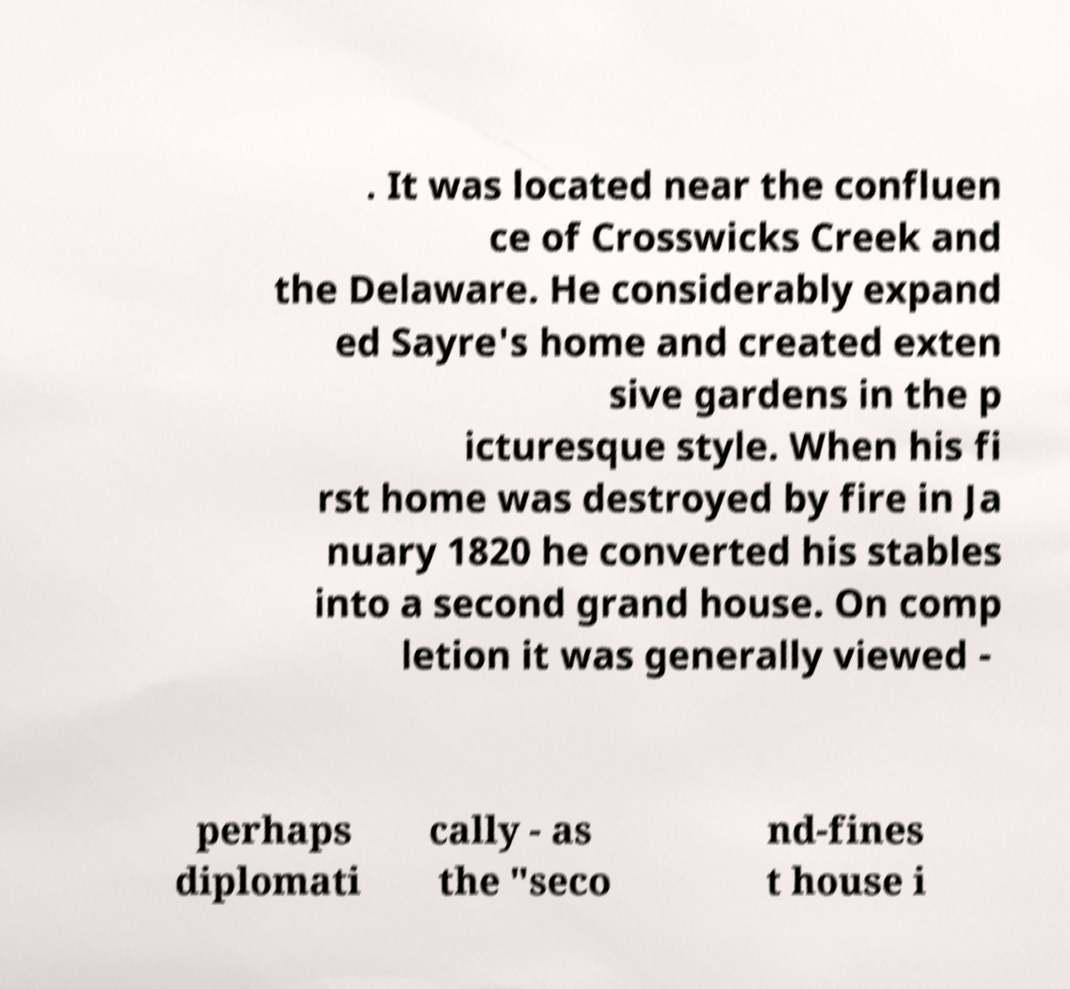Can you read and provide the text displayed in the image?This photo seems to have some interesting text. Can you extract and type it out for me? . It was located near the confluen ce of Crosswicks Creek and the Delaware. He considerably expand ed Sayre's home and created exten sive gardens in the p icturesque style. When his fi rst home was destroyed by fire in Ja nuary 1820 he converted his stables into a second grand house. On comp letion it was generally viewed - perhaps diplomati cally - as the "seco nd-fines t house i 